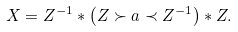Convert formula to latex. <formula><loc_0><loc_0><loc_500><loc_500>X = Z ^ { - 1 } * \left ( Z \succ a \prec Z ^ { - 1 } \right ) * Z .</formula> 